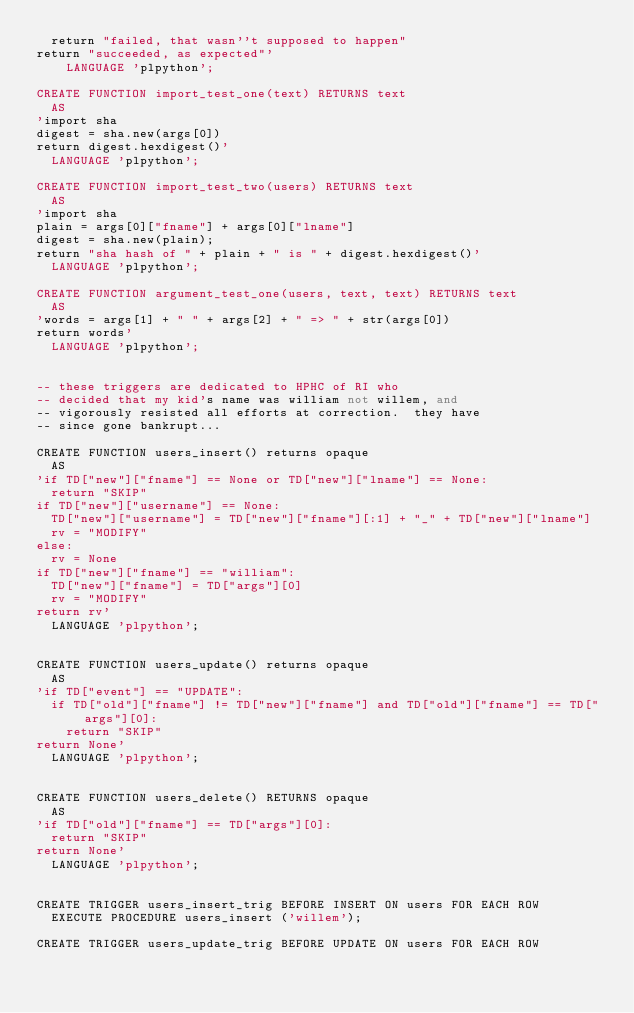<code> <loc_0><loc_0><loc_500><loc_500><_SQL_>	return "failed, that wasn''t supposed to happen"
return "succeeded, as expected"'
    LANGUAGE 'plpython';

CREATE FUNCTION import_test_one(text) RETURNS text
	AS
'import sha
digest = sha.new(args[0])
return digest.hexdigest()'
	LANGUAGE 'plpython';

CREATE FUNCTION import_test_two(users) RETURNS text
	AS
'import sha
plain = args[0]["fname"] + args[0]["lname"]
digest = sha.new(plain);
return "sha hash of " + plain + " is " + digest.hexdigest()'
	LANGUAGE 'plpython';

CREATE FUNCTION argument_test_one(users, text, text) RETURNS text
	AS
'words = args[1] + " " + args[2] + " => " + str(args[0])
return words'
	LANGUAGE 'plpython';


-- these triggers are dedicated to HPHC of RI who
-- decided that my kid's name was william not willem, and
-- vigorously resisted all efforts at correction.  they have
-- since gone bankrupt...

CREATE FUNCTION users_insert() returns opaque
	AS
'if TD["new"]["fname"] == None or TD["new"]["lname"] == None:
	return "SKIP"
if TD["new"]["username"] == None:
	TD["new"]["username"] = TD["new"]["fname"][:1] + "_" + TD["new"]["lname"]
	rv = "MODIFY"
else:
	rv = None
if TD["new"]["fname"] == "william":
	TD["new"]["fname"] = TD["args"][0]
	rv = "MODIFY"
return rv'
	LANGUAGE 'plpython';


CREATE FUNCTION users_update() returns opaque
	AS
'if TD["event"] == "UPDATE":
	if TD["old"]["fname"] != TD["new"]["fname"] and TD["old"]["fname"] == TD["args"][0]:
		return "SKIP"
return None'
	LANGUAGE 'plpython';


CREATE FUNCTION users_delete() RETURNS opaque
	AS
'if TD["old"]["fname"] == TD["args"][0]:
	return "SKIP"
return None'
	LANGUAGE 'plpython';


CREATE TRIGGER users_insert_trig BEFORE INSERT ON users FOR EACH ROW
	EXECUTE PROCEDURE users_insert ('willem');

CREATE TRIGGER users_update_trig BEFORE UPDATE ON users FOR EACH ROW</code> 